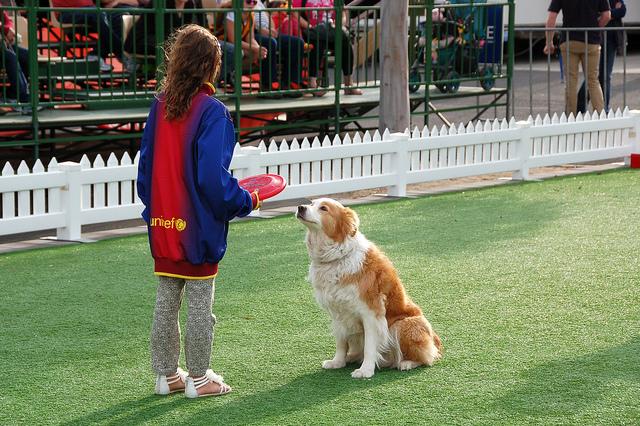Where is the person at?
Answer briefly. Dog show. What color is the dog?
Be succinct. Brown and white. How many dogs are there?
Short answer required. 1. 